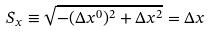<formula> <loc_0><loc_0><loc_500><loc_500>S _ { x } \equiv \sqrt { - ( \Delta x ^ { 0 } ) ^ { 2 } + \Delta x ^ { 2 } } = \Delta x</formula> 